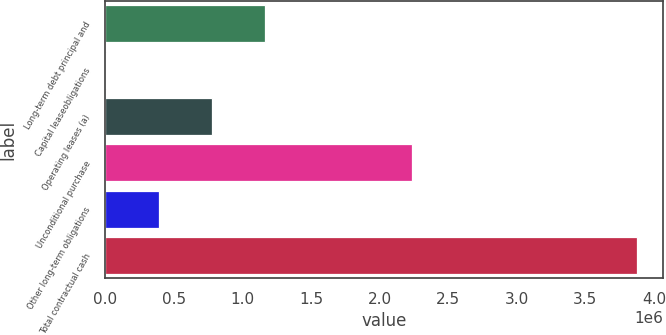<chart> <loc_0><loc_0><loc_500><loc_500><bar_chart><fcel>Long-term debt principal and<fcel>Capital leaseobligations<fcel>Operating leases (a)<fcel>Unconditional purchase<fcel>Other long-term obligations<fcel>Total contractual cash<nl><fcel>1.16679e+06<fcel>6286<fcel>779956<fcel>2.23954e+06<fcel>393121<fcel>3.87464e+06<nl></chart> 